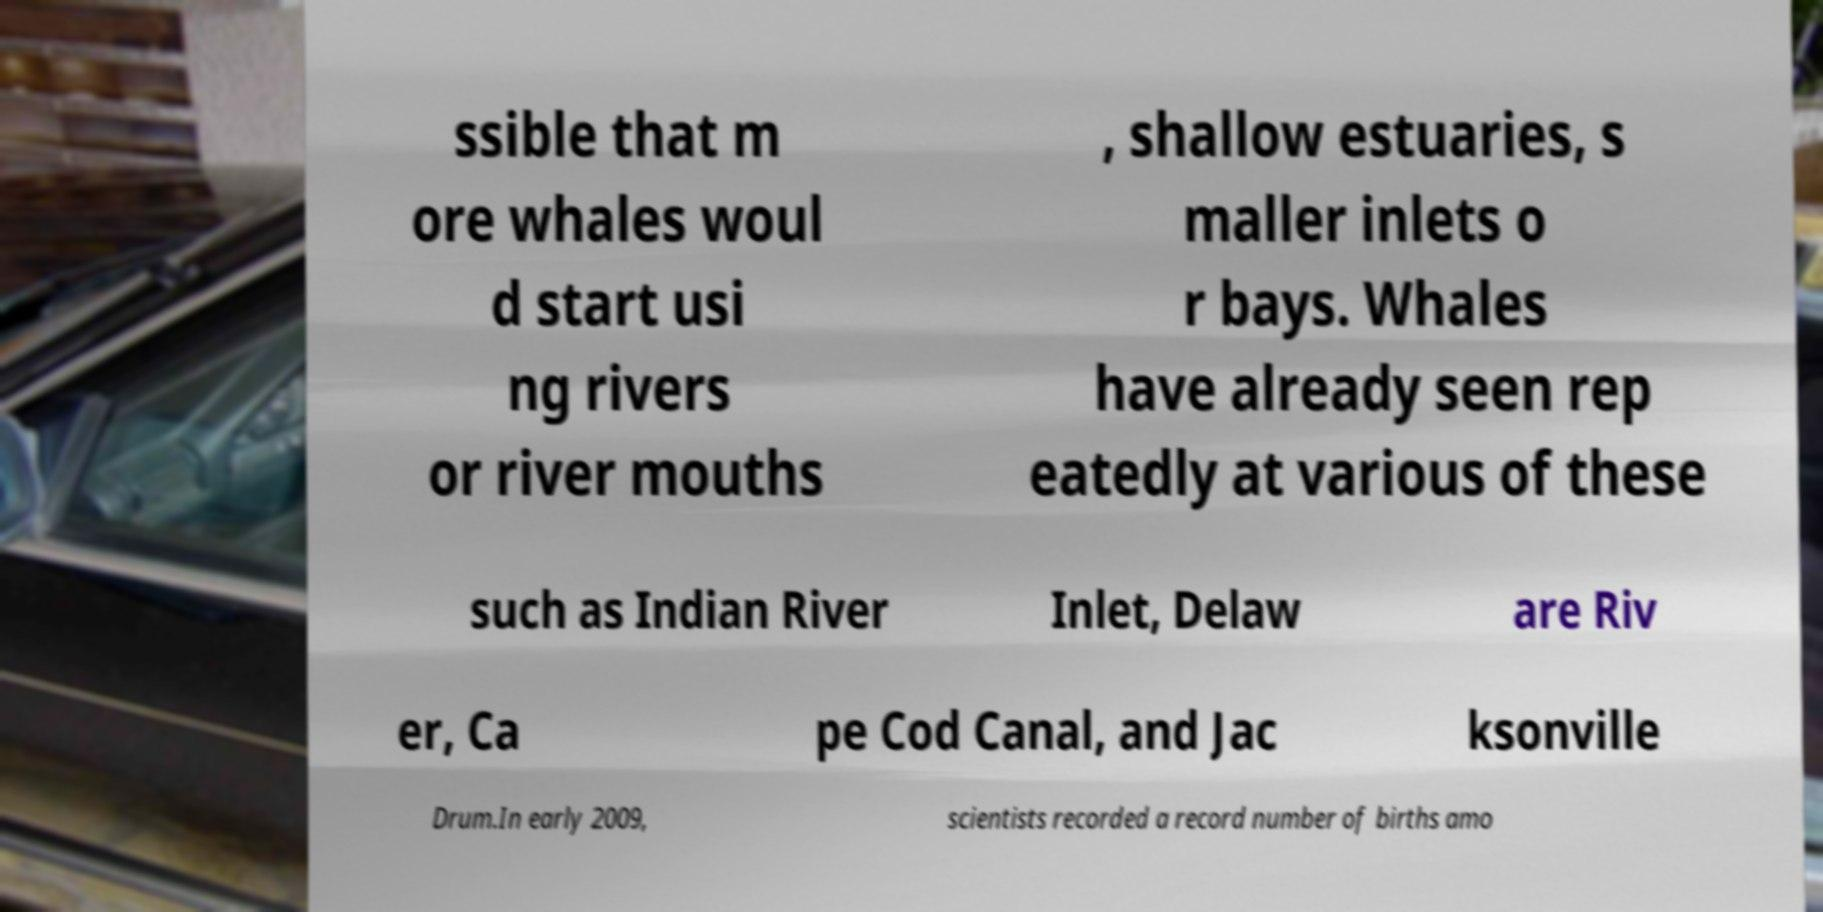Can you read and provide the text displayed in the image?This photo seems to have some interesting text. Can you extract and type it out for me? ssible that m ore whales woul d start usi ng rivers or river mouths , shallow estuaries, s maller inlets o r bays. Whales have already seen rep eatedly at various of these such as Indian River Inlet, Delaw are Riv er, Ca pe Cod Canal, and Jac ksonville Drum.In early 2009, scientists recorded a record number of births amo 